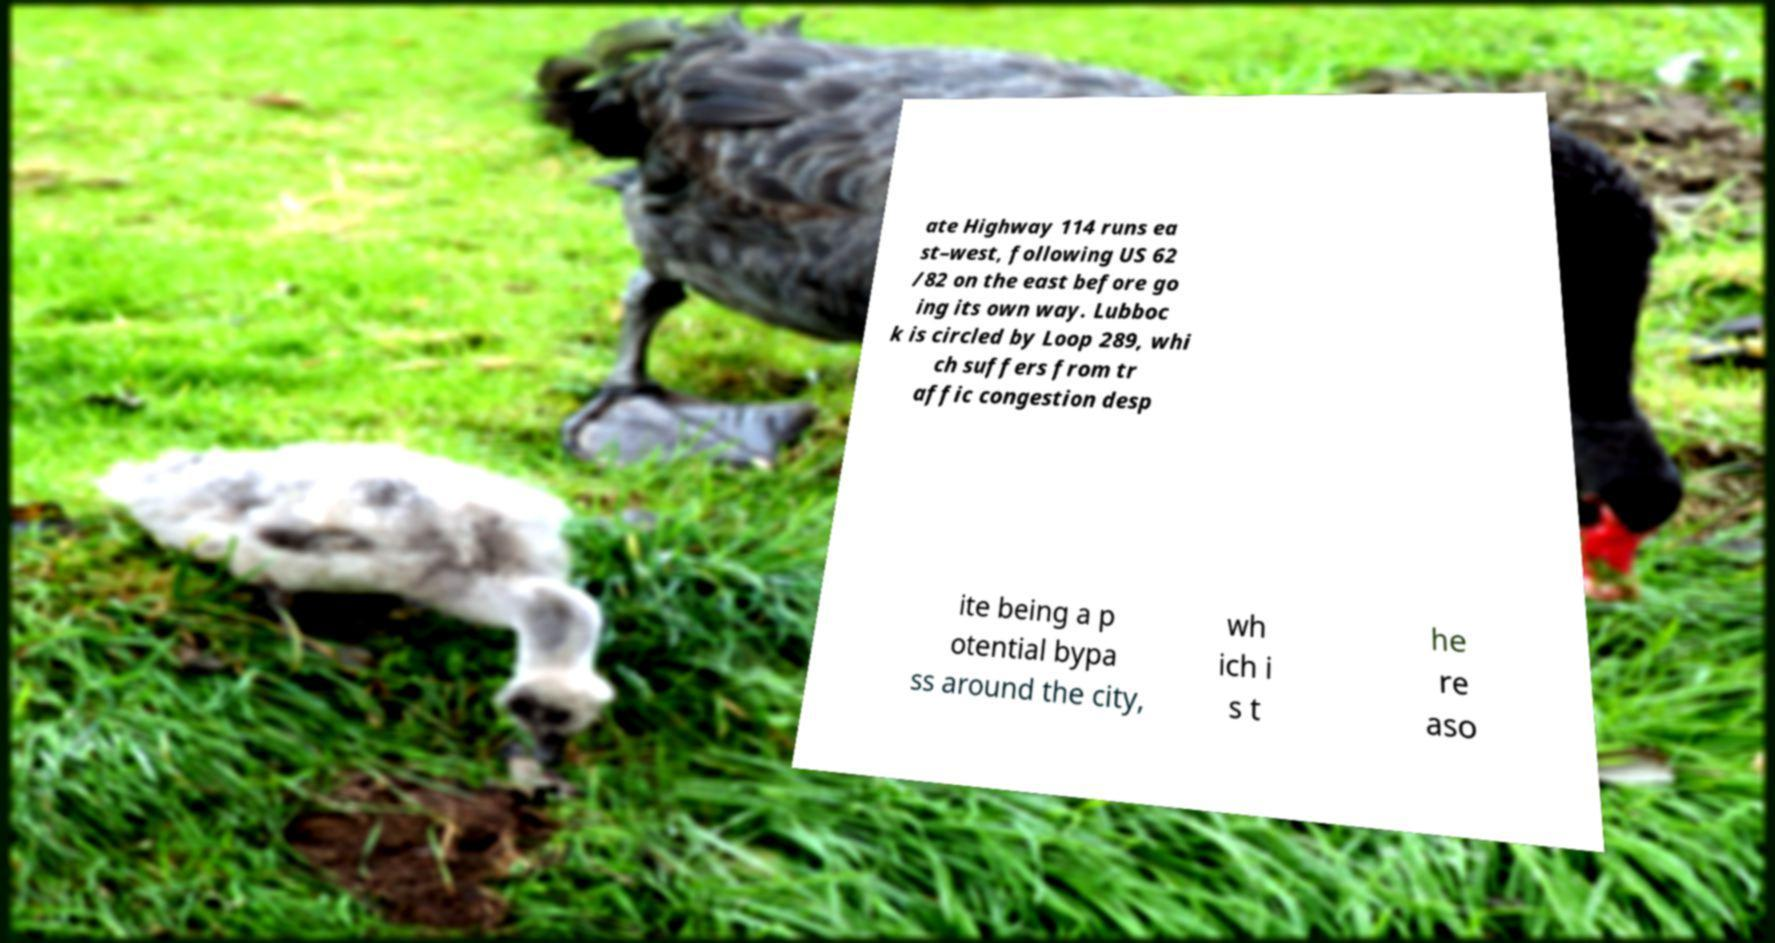Could you extract and type out the text from this image? ate Highway 114 runs ea st–west, following US 62 /82 on the east before go ing its own way. Lubboc k is circled by Loop 289, whi ch suffers from tr affic congestion desp ite being a p otential bypa ss around the city, wh ich i s t he re aso 